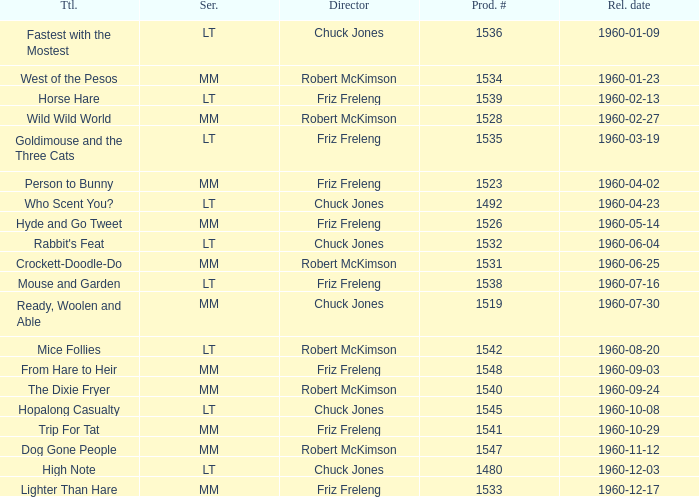What is the Series number of the episode with a production number of 1547? MM. 